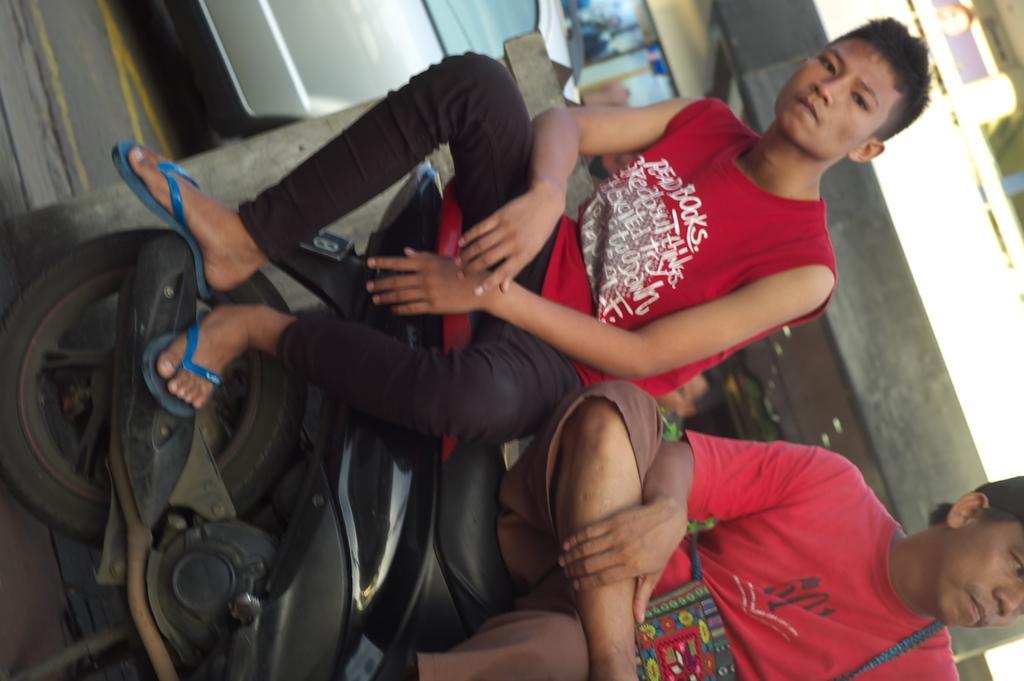Could you give a brief overview of what you see in this image? In this image we can see two persons are sitting on a bike and both of them are wearing a red color dress. 